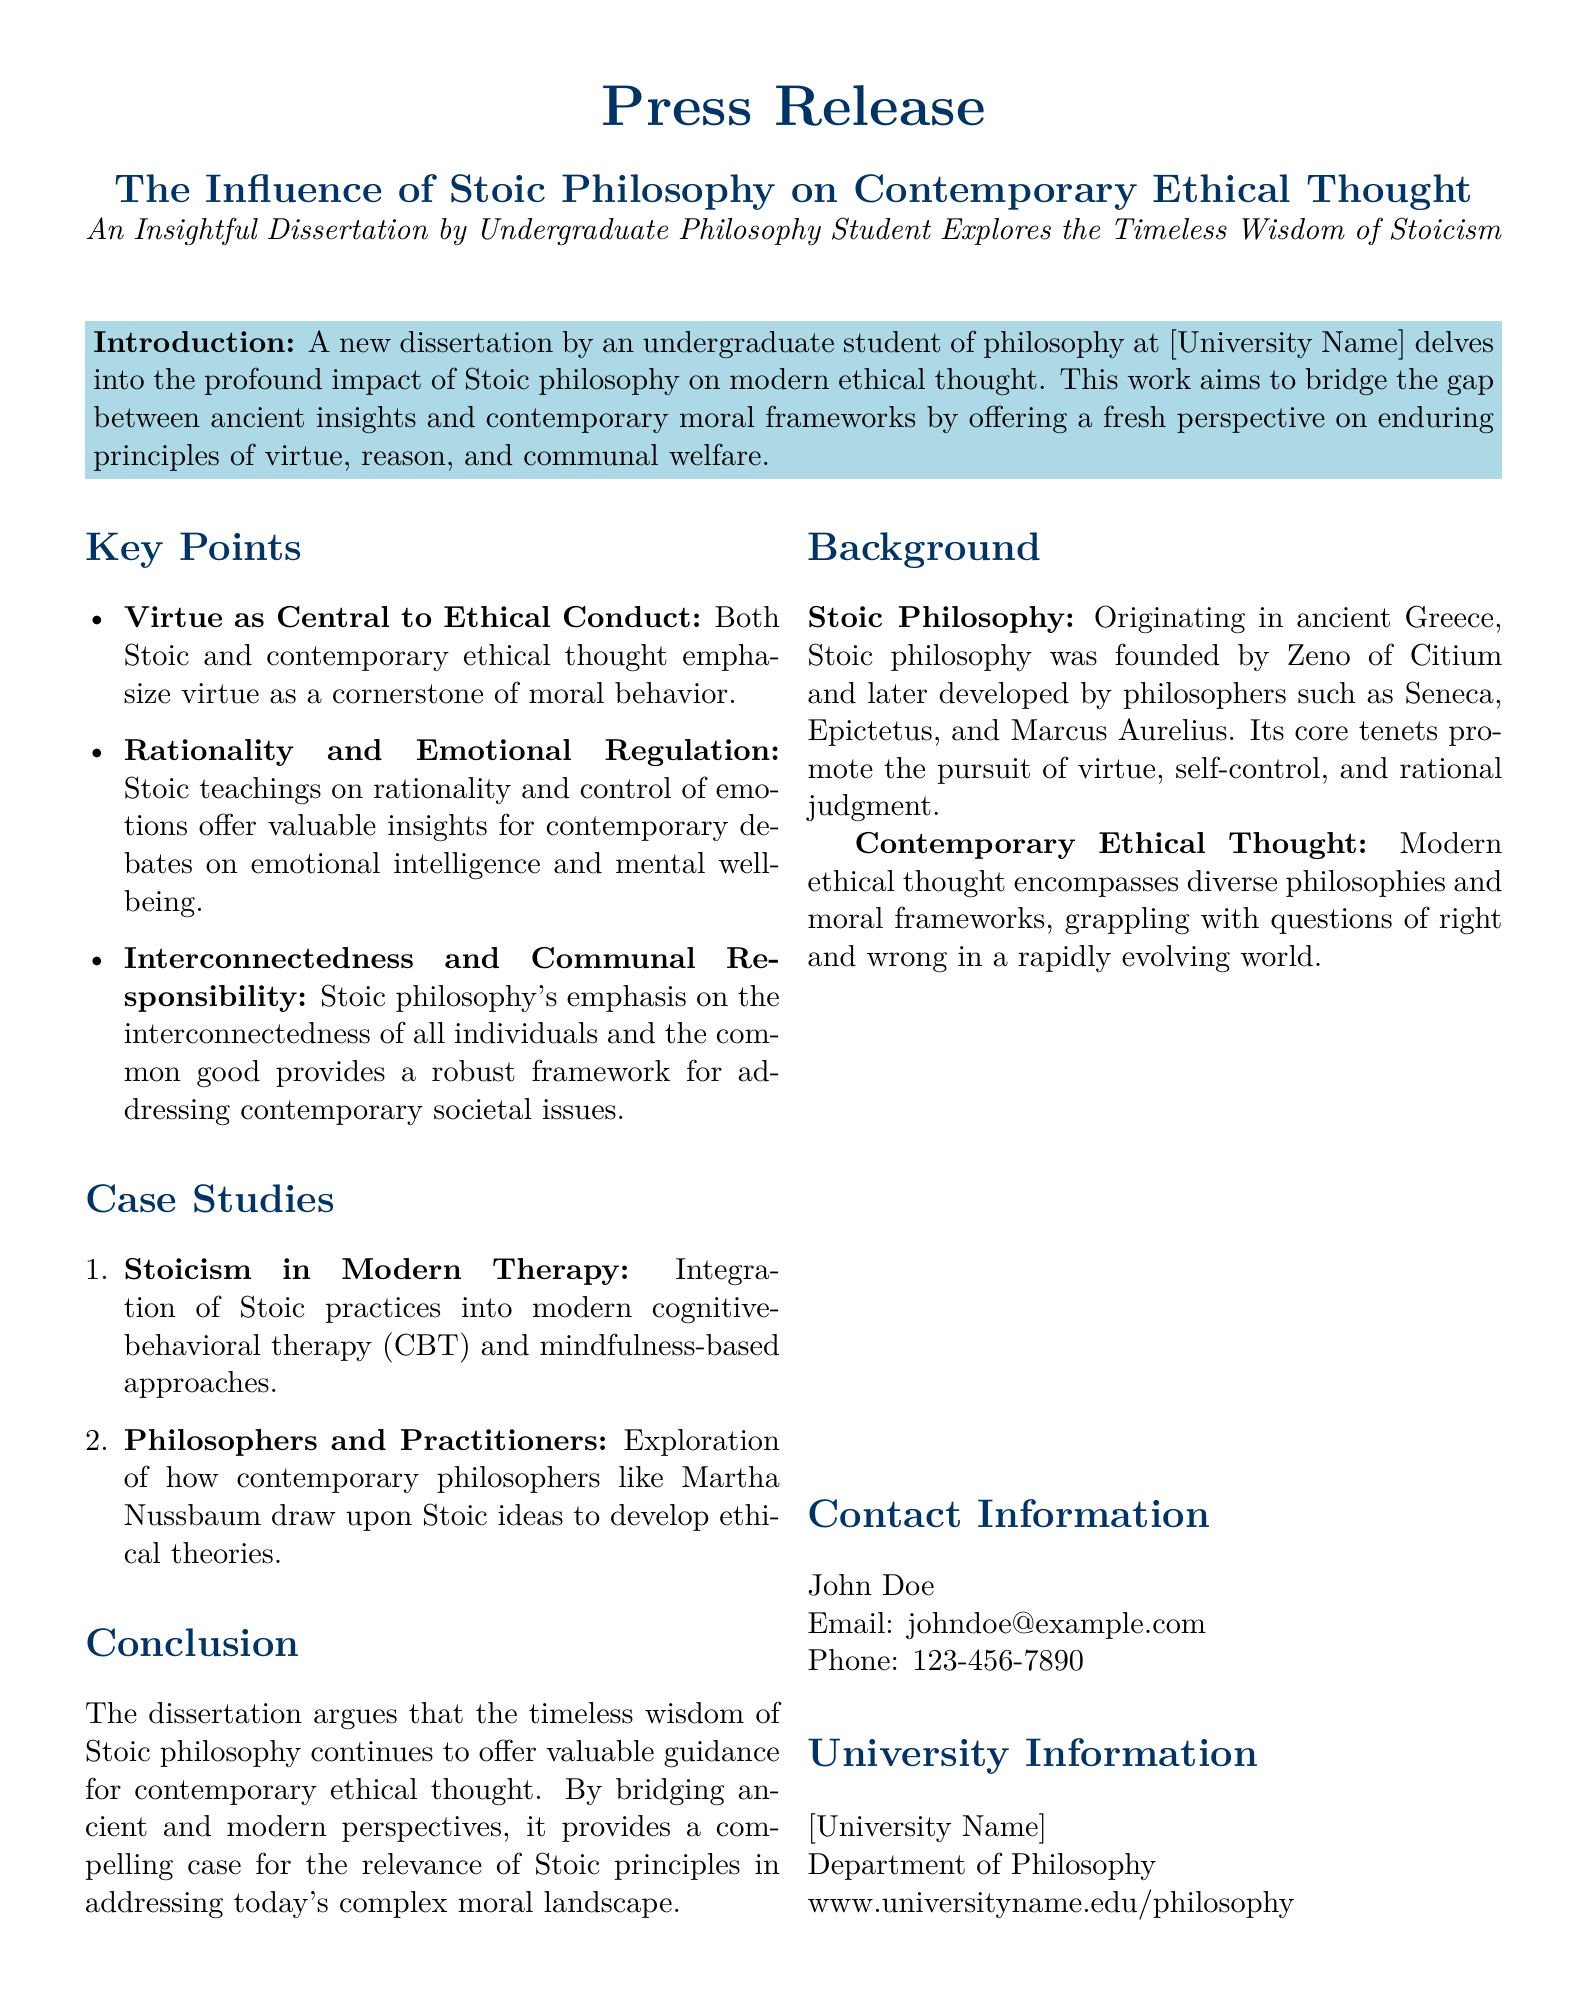What is the title of the dissertation? The title of the dissertation is specified in the press release, which mentions its focus on Stoic philosophy and contemporary ethical thought.
Answer: The Influence of Stoic Philosophy on Contemporary Ethical Thought Who is the author of the dissertation? The press release indicates the author as an undergraduate philosophy student without naming them directly.
Answer: An undergraduate philosophy student What university is associated with the dissertation? The dissertation is produced by a philosophy student at a particular university, which is noted in the document as [University Name].
Answer: [University Name] What is the primary focus of Stoic philosophy mentioned in the document? The primary focus of Stoic philosophy, as stated in the background section, includes several core tenets that are highlighted.
Answer: Virtue, self-control, and rational judgment What modern therapeutic approach integrates Stoic practices? The document discusses the integration of ancient Stoic practices into a contemporary method, which is specified as an approach to therapy.
Answer: Cognitive-behavioral therapy (CBT) Which contemporary philosopher is mentioned in connection to Stoic ideas? The press release refers to a modern philosopher who draws upon Stoic ideas to inform their ethical theories.
Answer: Martha Nussbaum What key aspect of Stoic philosophy is highlighted in addressing societal issues? The press release emphasizes a specific aspect of Stoic philosophy that addresses both individual and collective needs in society.
Answer: Interconnectedness and communal responsibility What is the overall argument of the dissertation? The conclusion of the dissertation provides an argument about the continuing relevance of Stoic principles in today's moral discussions.
Answer: Timeless wisdom of Stoic philosophy offers valuable guidance What type of document is this content derived from? The format and purpose of the text indicate its nature, which serves a particular function for disseminating information about academic work.
Answer: Press release 